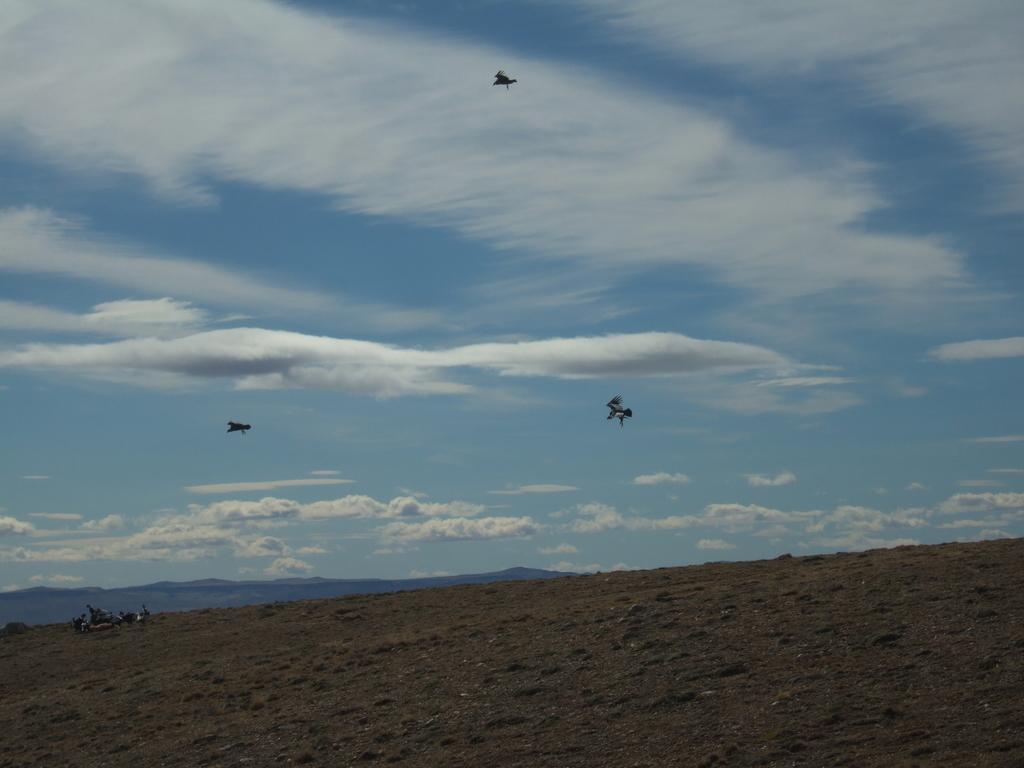Please provide a concise description of this image. In this picture I can see there are some mountains and there are birds in the sky. 